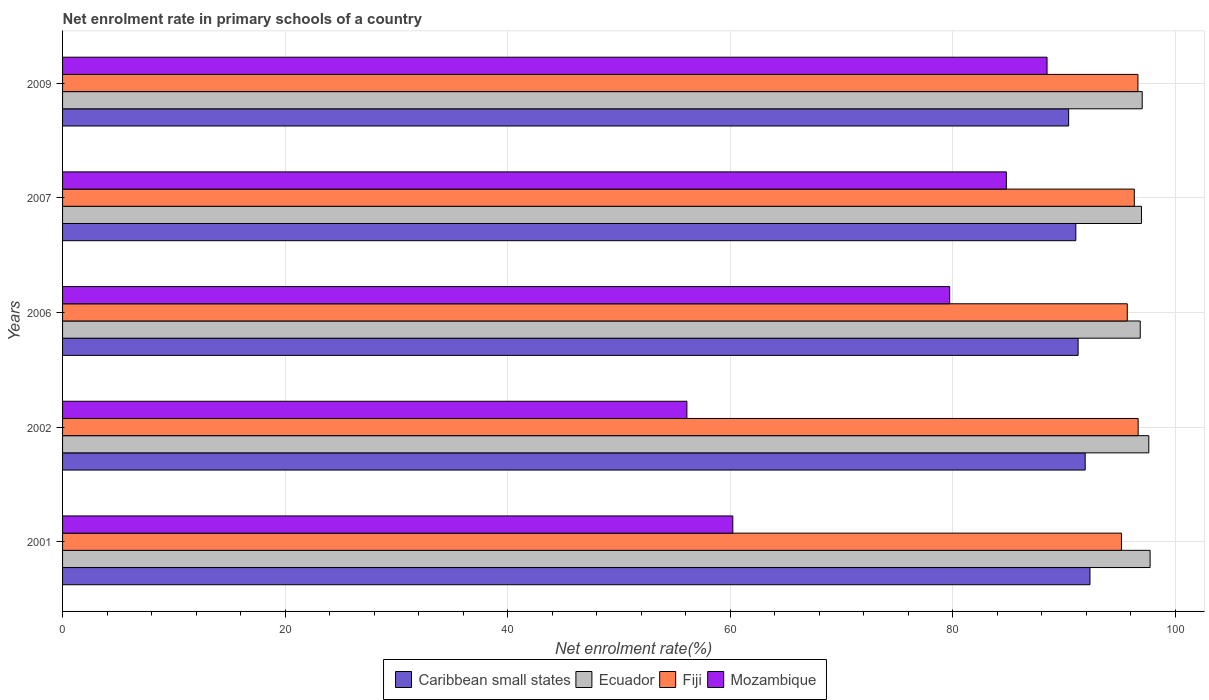How many groups of bars are there?
Give a very brief answer. 5. Are the number of bars per tick equal to the number of legend labels?
Your answer should be very brief. Yes. What is the label of the 5th group of bars from the top?
Your answer should be very brief. 2001. In how many cases, is the number of bars for a given year not equal to the number of legend labels?
Your answer should be very brief. 0. What is the net enrolment rate in primary schools in Mozambique in 2001?
Offer a terse response. 60.24. Across all years, what is the maximum net enrolment rate in primary schools in Caribbean small states?
Give a very brief answer. 92.34. Across all years, what is the minimum net enrolment rate in primary schools in Fiji?
Offer a terse response. 95.17. What is the total net enrolment rate in primary schools in Ecuador in the graph?
Your response must be concise. 486.24. What is the difference between the net enrolment rate in primary schools in Ecuador in 2001 and that in 2007?
Make the answer very short. 0.78. What is the difference between the net enrolment rate in primary schools in Mozambique in 2009 and the net enrolment rate in primary schools in Caribbean small states in 2002?
Offer a very short reply. -3.43. What is the average net enrolment rate in primary schools in Ecuador per year?
Ensure brevity in your answer.  97.25. In the year 2007, what is the difference between the net enrolment rate in primary schools in Mozambique and net enrolment rate in primary schools in Fiji?
Your answer should be very brief. -11.5. In how many years, is the net enrolment rate in primary schools in Fiji greater than 80 %?
Your response must be concise. 5. What is the ratio of the net enrolment rate in primary schools in Ecuador in 2001 to that in 2002?
Offer a very short reply. 1. Is the net enrolment rate in primary schools in Caribbean small states in 2001 less than that in 2009?
Your response must be concise. No. Is the difference between the net enrolment rate in primary schools in Mozambique in 2007 and 2009 greater than the difference between the net enrolment rate in primary schools in Fiji in 2007 and 2009?
Make the answer very short. No. What is the difference between the highest and the second highest net enrolment rate in primary schools in Fiji?
Your answer should be compact. 0.02. What is the difference between the highest and the lowest net enrolment rate in primary schools in Ecuador?
Provide a succinct answer. 0.89. In how many years, is the net enrolment rate in primary schools in Caribbean small states greater than the average net enrolment rate in primary schools in Caribbean small states taken over all years?
Your response must be concise. 2. Is it the case that in every year, the sum of the net enrolment rate in primary schools in Ecuador and net enrolment rate in primary schools in Caribbean small states is greater than the sum of net enrolment rate in primary schools in Fiji and net enrolment rate in primary schools in Mozambique?
Make the answer very short. No. What does the 2nd bar from the top in 2006 represents?
Offer a very short reply. Fiji. What does the 2nd bar from the bottom in 2006 represents?
Your answer should be compact. Ecuador. Is it the case that in every year, the sum of the net enrolment rate in primary schools in Ecuador and net enrolment rate in primary schools in Caribbean small states is greater than the net enrolment rate in primary schools in Fiji?
Provide a succinct answer. Yes. How many years are there in the graph?
Provide a succinct answer. 5. Are the values on the major ticks of X-axis written in scientific E-notation?
Provide a succinct answer. No. How many legend labels are there?
Provide a succinct answer. 4. What is the title of the graph?
Your answer should be very brief. Net enrolment rate in primary schools of a country. What is the label or title of the X-axis?
Offer a very short reply. Net enrolment rate(%). What is the label or title of the Y-axis?
Your response must be concise. Years. What is the Net enrolment rate(%) of Caribbean small states in 2001?
Make the answer very short. 92.34. What is the Net enrolment rate(%) of Ecuador in 2001?
Your answer should be compact. 97.75. What is the Net enrolment rate(%) in Fiji in 2001?
Give a very brief answer. 95.17. What is the Net enrolment rate(%) of Mozambique in 2001?
Offer a very short reply. 60.24. What is the Net enrolment rate(%) in Caribbean small states in 2002?
Offer a very short reply. 91.91. What is the Net enrolment rate(%) in Ecuador in 2002?
Ensure brevity in your answer.  97.63. What is the Net enrolment rate(%) of Fiji in 2002?
Your response must be concise. 96.67. What is the Net enrolment rate(%) of Mozambique in 2002?
Offer a very short reply. 56.11. What is the Net enrolment rate(%) of Caribbean small states in 2006?
Your response must be concise. 91.28. What is the Net enrolment rate(%) of Ecuador in 2006?
Keep it short and to the point. 96.86. What is the Net enrolment rate(%) of Fiji in 2006?
Your answer should be compact. 95.69. What is the Net enrolment rate(%) in Mozambique in 2006?
Your answer should be compact. 79.73. What is the Net enrolment rate(%) in Caribbean small states in 2007?
Your answer should be compact. 91.07. What is the Net enrolment rate(%) in Ecuador in 2007?
Keep it short and to the point. 96.97. What is the Net enrolment rate(%) of Fiji in 2007?
Keep it short and to the point. 96.33. What is the Net enrolment rate(%) of Mozambique in 2007?
Your answer should be compact. 84.83. What is the Net enrolment rate(%) of Caribbean small states in 2009?
Ensure brevity in your answer.  90.42. What is the Net enrolment rate(%) of Ecuador in 2009?
Offer a very short reply. 97.04. What is the Net enrolment rate(%) of Fiji in 2009?
Your answer should be very brief. 96.65. What is the Net enrolment rate(%) in Mozambique in 2009?
Your response must be concise. 88.48. Across all years, what is the maximum Net enrolment rate(%) in Caribbean small states?
Offer a very short reply. 92.34. Across all years, what is the maximum Net enrolment rate(%) of Ecuador?
Give a very brief answer. 97.75. Across all years, what is the maximum Net enrolment rate(%) in Fiji?
Make the answer very short. 96.67. Across all years, what is the maximum Net enrolment rate(%) of Mozambique?
Ensure brevity in your answer.  88.48. Across all years, what is the minimum Net enrolment rate(%) of Caribbean small states?
Provide a succinct answer. 90.42. Across all years, what is the minimum Net enrolment rate(%) in Ecuador?
Make the answer very short. 96.86. Across all years, what is the minimum Net enrolment rate(%) in Fiji?
Keep it short and to the point. 95.17. Across all years, what is the minimum Net enrolment rate(%) in Mozambique?
Offer a terse response. 56.11. What is the total Net enrolment rate(%) in Caribbean small states in the graph?
Offer a very short reply. 457.02. What is the total Net enrolment rate(%) in Ecuador in the graph?
Your response must be concise. 486.24. What is the total Net enrolment rate(%) of Fiji in the graph?
Keep it short and to the point. 480.51. What is the total Net enrolment rate(%) of Mozambique in the graph?
Provide a succinct answer. 369.39. What is the difference between the Net enrolment rate(%) of Caribbean small states in 2001 and that in 2002?
Your answer should be very brief. 0.43. What is the difference between the Net enrolment rate(%) of Ecuador in 2001 and that in 2002?
Provide a short and direct response. 0.12. What is the difference between the Net enrolment rate(%) of Fiji in 2001 and that in 2002?
Keep it short and to the point. -1.5. What is the difference between the Net enrolment rate(%) of Mozambique in 2001 and that in 2002?
Your answer should be very brief. 4.13. What is the difference between the Net enrolment rate(%) in Caribbean small states in 2001 and that in 2006?
Offer a terse response. 1.06. What is the difference between the Net enrolment rate(%) of Ecuador in 2001 and that in 2006?
Your answer should be very brief. 0.89. What is the difference between the Net enrolment rate(%) in Fiji in 2001 and that in 2006?
Give a very brief answer. -0.52. What is the difference between the Net enrolment rate(%) in Mozambique in 2001 and that in 2006?
Provide a short and direct response. -19.49. What is the difference between the Net enrolment rate(%) of Caribbean small states in 2001 and that in 2007?
Your answer should be compact. 1.27. What is the difference between the Net enrolment rate(%) in Ecuador in 2001 and that in 2007?
Your response must be concise. 0.78. What is the difference between the Net enrolment rate(%) of Fiji in 2001 and that in 2007?
Your answer should be compact. -1.15. What is the difference between the Net enrolment rate(%) in Mozambique in 2001 and that in 2007?
Your answer should be compact. -24.59. What is the difference between the Net enrolment rate(%) in Caribbean small states in 2001 and that in 2009?
Your response must be concise. 1.92. What is the difference between the Net enrolment rate(%) of Ecuador in 2001 and that in 2009?
Offer a terse response. 0.71. What is the difference between the Net enrolment rate(%) in Fiji in 2001 and that in 2009?
Ensure brevity in your answer.  -1.48. What is the difference between the Net enrolment rate(%) in Mozambique in 2001 and that in 2009?
Offer a terse response. -28.24. What is the difference between the Net enrolment rate(%) of Caribbean small states in 2002 and that in 2006?
Your answer should be very brief. 0.63. What is the difference between the Net enrolment rate(%) in Ecuador in 2002 and that in 2006?
Your response must be concise. 0.77. What is the difference between the Net enrolment rate(%) in Fiji in 2002 and that in 2006?
Offer a very short reply. 0.98. What is the difference between the Net enrolment rate(%) of Mozambique in 2002 and that in 2006?
Provide a short and direct response. -23.62. What is the difference between the Net enrolment rate(%) in Caribbean small states in 2002 and that in 2007?
Ensure brevity in your answer.  0.84. What is the difference between the Net enrolment rate(%) in Ecuador in 2002 and that in 2007?
Keep it short and to the point. 0.66. What is the difference between the Net enrolment rate(%) of Fiji in 2002 and that in 2007?
Make the answer very short. 0.35. What is the difference between the Net enrolment rate(%) in Mozambique in 2002 and that in 2007?
Give a very brief answer. -28.71. What is the difference between the Net enrolment rate(%) in Caribbean small states in 2002 and that in 2009?
Provide a short and direct response. 1.49. What is the difference between the Net enrolment rate(%) of Ecuador in 2002 and that in 2009?
Your answer should be compact. 0.59. What is the difference between the Net enrolment rate(%) in Fiji in 2002 and that in 2009?
Offer a very short reply. 0.02. What is the difference between the Net enrolment rate(%) in Mozambique in 2002 and that in 2009?
Your answer should be compact. -32.37. What is the difference between the Net enrolment rate(%) of Caribbean small states in 2006 and that in 2007?
Offer a terse response. 0.21. What is the difference between the Net enrolment rate(%) in Ecuador in 2006 and that in 2007?
Give a very brief answer. -0.11. What is the difference between the Net enrolment rate(%) in Fiji in 2006 and that in 2007?
Your answer should be compact. -0.63. What is the difference between the Net enrolment rate(%) of Mozambique in 2006 and that in 2007?
Keep it short and to the point. -5.1. What is the difference between the Net enrolment rate(%) in Caribbean small states in 2006 and that in 2009?
Give a very brief answer. 0.85. What is the difference between the Net enrolment rate(%) in Ecuador in 2006 and that in 2009?
Ensure brevity in your answer.  -0.18. What is the difference between the Net enrolment rate(%) in Fiji in 2006 and that in 2009?
Your answer should be very brief. -0.96. What is the difference between the Net enrolment rate(%) of Mozambique in 2006 and that in 2009?
Offer a very short reply. -8.75. What is the difference between the Net enrolment rate(%) in Caribbean small states in 2007 and that in 2009?
Provide a succinct answer. 0.65. What is the difference between the Net enrolment rate(%) in Ecuador in 2007 and that in 2009?
Make the answer very short. -0.07. What is the difference between the Net enrolment rate(%) in Fiji in 2007 and that in 2009?
Ensure brevity in your answer.  -0.33. What is the difference between the Net enrolment rate(%) in Mozambique in 2007 and that in 2009?
Provide a succinct answer. -3.66. What is the difference between the Net enrolment rate(%) of Caribbean small states in 2001 and the Net enrolment rate(%) of Ecuador in 2002?
Ensure brevity in your answer.  -5.29. What is the difference between the Net enrolment rate(%) of Caribbean small states in 2001 and the Net enrolment rate(%) of Fiji in 2002?
Give a very brief answer. -4.33. What is the difference between the Net enrolment rate(%) in Caribbean small states in 2001 and the Net enrolment rate(%) in Mozambique in 2002?
Keep it short and to the point. 36.23. What is the difference between the Net enrolment rate(%) in Ecuador in 2001 and the Net enrolment rate(%) in Fiji in 2002?
Offer a very short reply. 1.07. What is the difference between the Net enrolment rate(%) in Ecuador in 2001 and the Net enrolment rate(%) in Mozambique in 2002?
Ensure brevity in your answer.  41.63. What is the difference between the Net enrolment rate(%) in Fiji in 2001 and the Net enrolment rate(%) in Mozambique in 2002?
Provide a succinct answer. 39.06. What is the difference between the Net enrolment rate(%) in Caribbean small states in 2001 and the Net enrolment rate(%) in Ecuador in 2006?
Offer a very short reply. -4.52. What is the difference between the Net enrolment rate(%) in Caribbean small states in 2001 and the Net enrolment rate(%) in Fiji in 2006?
Make the answer very short. -3.35. What is the difference between the Net enrolment rate(%) in Caribbean small states in 2001 and the Net enrolment rate(%) in Mozambique in 2006?
Give a very brief answer. 12.61. What is the difference between the Net enrolment rate(%) in Ecuador in 2001 and the Net enrolment rate(%) in Fiji in 2006?
Your response must be concise. 2.05. What is the difference between the Net enrolment rate(%) of Ecuador in 2001 and the Net enrolment rate(%) of Mozambique in 2006?
Provide a short and direct response. 18.02. What is the difference between the Net enrolment rate(%) of Fiji in 2001 and the Net enrolment rate(%) of Mozambique in 2006?
Your response must be concise. 15.44. What is the difference between the Net enrolment rate(%) of Caribbean small states in 2001 and the Net enrolment rate(%) of Ecuador in 2007?
Offer a terse response. -4.63. What is the difference between the Net enrolment rate(%) of Caribbean small states in 2001 and the Net enrolment rate(%) of Fiji in 2007?
Give a very brief answer. -3.99. What is the difference between the Net enrolment rate(%) of Caribbean small states in 2001 and the Net enrolment rate(%) of Mozambique in 2007?
Make the answer very short. 7.51. What is the difference between the Net enrolment rate(%) of Ecuador in 2001 and the Net enrolment rate(%) of Fiji in 2007?
Keep it short and to the point. 1.42. What is the difference between the Net enrolment rate(%) of Ecuador in 2001 and the Net enrolment rate(%) of Mozambique in 2007?
Your answer should be compact. 12.92. What is the difference between the Net enrolment rate(%) of Fiji in 2001 and the Net enrolment rate(%) of Mozambique in 2007?
Give a very brief answer. 10.35. What is the difference between the Net enrolment rate(%) in Caribbean small states in 2001 and the Net enrolment rate(%) in Ecuador in 2009?
Your response must be concise. -4.7. What is the difference between the Net enrolment rate(%) in Caribbean small states in 2001 and the Net enrolment rate(%) in Fiji in 2009?
Ensure brevity in your answer.  -4.31. What is the difference between the Net enrolment rate(%) in Caribbean small states in 2001 and the Net enrolment rate(%) in Mozambique in 2009?
Make the answer very short. 3.86. What is the difference between the Net enrolment rate(%) in Ecuador in 2001 and the Net enrolment rate(%) in Fiji in 2009?
Provide a short and direct response. 1.1. What is the difference between the Net enrolment rate(%) in Ecuador in 2001 and the Net enrolment rate(%) in Mozambique in 2009?
Your answer should be very brief. 9.26. What is the difference between the Net enrolment rate(%) in Fiji in 2001 and the Net enrolment rate(%) in Mozambique in 2009?
Your answer should be very brief. 6.69. What is the difference between the Net enrolment rate(%) of Caribbean small states in 2002 and the Net enrolment rate(%) of Ecuador in 2006?
Your answer should be very brief. -4.95. What is the difference between the Net enrolment rate(%) in Caribbean small states in 2002 and the Net enrolment rate(%) in Fiji in 2006?
Keep it short and to the point. -3.78. What is the difference between the Net enrolment rate(%) of Caribbean small states in 2002 and the Net enrolment rate(%) of Mozambique in 2006?
Provide a short and direct response. 12.18. What is the difference between the Net enrolment rate(%) in Ecuador in 2002 and the Net enrolment rate(%) in Fiji in 2006?
Make the answer very short. 1.94. What is the difference between the Net enrolment rate(%) in Ecuador in 2002 and the Net enrolment rate(%) in Mozambique in 2006?
Your answer should be compact. 17.9. What is the difference between the Net enrolment rate(%) of Fiji in 2002 and the Net enrolment rate(%) of Mozambique in 2006?
Ensure brevity in your answer.  16.94. What is the difference between the Net enrolment rate(%) of Caribbean small states in 2002 and the Net enrolment rate(%) of Ecuador in 2007?
Your answer should be very brief. -5.06. What is the difference between the Net enrolment rate(%) of Caribbean small states in 2002 and the Net enrolment rate(%) of Fiji in 2007?
Your answer should be compact. -4.42. What is the difference between the Net enrolment rate(%) in Caribbean small states in 2002 and the Net enrolment rate(%) in Mozambique in 2007?
Offer a very short reply. 7.09. What is the difference between the Net enrolment rate(%) in Ecuador in 2002 and the Net enrolment rate(%) in Fiji in 2007?
Ensure brevity in your answer.  1.3. What is the difference between the Net enrolment rate(%) in Ecuador in 2002 and the Net enrolment rate(%) in Mozambique in 2007?
Make the answer very short. 12.8. What is the difference between the Net enrolment rate(%) of Fiji in 2002 and the Net enrolment rate(%) of Mozambique in 2007?
Provide a short and direct response. 11.85. What is the difference between the Net enrolment rate(%) of Caribbean small states in 2002 and the Net enrolment rate(%) of Ecuador in 2009?
Provide a short and direct response. -5.12. What is the difference between the Net enrolment rate(%) in Caribbean small states in 2002 and the Net enrolment rate(%) in Fiji in 2009?
Offer a terse response. -4.74. What is the difference between the Net enrolment rate(%) in Caribbean small states in 2002 and the Net enrolment rate(%) in Mozambique in 2009?
Your answer should be compact. 3.43. What is the difference between the Net enrolment rate(%) in Ecuador in 2002 and the Net enrolment rate(%) in Fiji in 2009?
Provide a succinct answer. 0.98. What is the difference between the Net enrolment rate(%) in Ecuador in 2002 and the Net enrolment rate(%) in Mozambique in 2009?
Provide a short and direct response. 9.15. What is the difference between the Net enrolment rate(%) in Fiji in 2002 and the Net enrolment rate(%) in Mozambique in 2009?
Provide a succinct answer. 8.19. What is the difference between the Net enrolment rate(%) of Caribbean small states in 2006 and the Net enrolment rate(%) of Ecuador in 2007?
Provide a succinct answer. -5.69. What is the difference between the Net enrolment rate(%) of Caribbean small states in 2006 and the Net enrolment rate(%) of Fiji in 2007?
Provide a succinct answer. -5.05. What is the difference between the Net enrolment rate(%) of Caribbean small states in 2006 and the Net enrolment rate(%) of Mozambique in 2007?
Give a very brief answer. 6.45. What is the difference between the Net enrolment rate(%) of Ecuador in 2006 and the Net enrolment rate(%) of Fiji in 2007?
Provide a short and direct response. 0.53. What is the difference between the Net enrolment rate(%) of Ecuador in 2006 and the Net enrolment rate(%) of Mozambique in 2007?
Ensure brevity in your answer.  12.03. What is the difference between the Net enrolment rate(%) of Fiji in 2006 and the Net enrolment rate(%) of Mozambique in 2007?
Provide a succinct answer. 10.87. What is the difference between the Net enrolment rate(%) of Caribbean small states in 2006 and the Net enrolment rate(%) of Ecuador in 2009?
Provide a short and direct response. -5.76. What is the difference between the Net enrolment rate(%) in Caribbean small states in 2006 and the Net enrolment rate(%) in Fiji in 2009?
Your answer should be very brief. -5.38. What is the difference between the Net enrolment rate(%) in Caribbean small states in 2006 and the Net enrolment rate(%) in Mozambique in 2009?
Keep it short and to the point. 2.79. What is the difference between the Net enrolment rate(%) of Ecuador in 2006 and the Net enrolment rate(%) of Fiji in 2009?
Provide a short and direct response. 0.21. What is the difference between the Net enrolment rate(%) of Ecuador in 2006 and the Net enrolment rate(%) of Mozambique in 2009?
Make the answer very short. 8.38. What is the difference between the Net enrolment rate(%) of Fiji in 2006 and the Net enrolment rate(%) of Mozambique in 2009?
Provide a short and direct response. 7.21. What is the difference between the Net enrolment rate(%) of Caribbean small states in 2007 and the Net enrolment rate(%) of Ecuador in 2009?
Offer a very short reply. -5.97. What is the difference between the Net enrolment rate(%) in Caribbean small states in 2007 and the Net enrolment rate(%) in Fiji in 2009?
Offer a very short reply. -5.58. What is the difference between the Net enrolment rate(%) in Caribbean small states in 2007 and the Net enrolment rate(%) in Mozambique in 2009?
Your answer should be very brief. 2.59. What is the difference between the Net enrolment rate(%) of Ecuador in 2007 and the Net enrolment rate(%) of Fiji in 2009?
Keep it short and to the point. 0.32. What is the difference between the Net enrolment rate(%) of Ecuador in 2007 and the Net enrolment rate(%) of Mozambique in 2009?
Make the answer very short. 8.49. What is the difference between the Net enrolment rate(%) of Fiji in 2007 and the Net enrolment rate(%) of Mozambique in 2009?
Your answer should be compact. 7.84. What is the average Net enrolment rate(%) in Caribbean small states per year?
Ensure brevity in your answer.  91.4. What is the average Net enrolment rate(%) in Ecuador per year?
Offer a very short reply. 97.25. What is the average Net enrolment rate(%) in Fiji per year?
Your answer should be compact. 96.1. What is the average Net enrolment rate(%) of Mozambique per year?
Your answer should be very brief. 73.88. In the year 2001, what is the difference between the Net enrolment rate(%) of Caribbean small states and Net enrolment rate(%) of Ecuador?
Offer a terse response. -5.41. In the year 2001, what is the difference between the Net enrolment rate(%) in Caribbean small states and Net enrolment rate(%) in Fiji?
Ensure brevity in your answer.  -2.83. In the year 2001, what is the difference between the Net enrolment rate(%) of Caribbean small states and Net enrolment rate(%) of Mozambique?
Your answer should be very brief. 32.1. In the year 2001, what is the difference between the Net enrolment rate(%) in Ecuador and Net enrolment rate(%) in Fiji?
Your answer should be very brief. 2.58. In the year 2001, what is the difference between the Net enrolment rate(%) of Ecuador and Net enrolment rate(%) of Mozambique?
Your answer should be compact. 37.51. In the year 2001, what is the difference between the Net enrolment rate(%) in Fiji and Net enrolment rate(%) in Mozambique?
Your answer should be very brief. 34.93. In the year 2002, what is the difference between the Net enrolment rate(%) of Caribbean small states and Net enrolment rate(%) of Ecuador?
Offer a very short reply. -5.72. In the year 2002, what is the difference between the Net enrolment rate(%) in Caribbean small states and Net enrolment rate(%) in Fiji?
Provide a succinct answer. -4.76. In the year 2002, what is the difference between the Net enrolment rate(%) in Caribbean small states and Net enrolment rate(%) in Mozambique?
Offer a very short reply. 35.8. In the year 2002, what is the difference between the Net enrolment rate(%) in Ecuador and Net enrolment rate(%) in Fiji?
Ensure brevity in your answer.  0.96. In the year 2002, what is the difference between the Net enrolment rate(%) in Ecuador and Net enrolment rate(%) in Mozambique?
Offer a very short reply. 41.52. In the year 2002, what is the difference between the Net enrolment rate(%) of Fiji and Net enrolment rate(%) of Mozambique?
Give a very brief answer. 40.56. In the year 2006, what is the difference between the Net enrolment rate(%) in Caribbean small states and Net enrolment rate(%) in Ecuador?
Offer a very short reply. -5.58. In the year 2006, what is the difference between the Net enrolment rate(%) in Caribbean small states and Net enrolment rate(%) in Fiji?
Provide a short and direct response. -4.42. In the year 2006, what is the difference between the Net enrolment rate(%) in Caribbean small states and Net enrolment rate(%) in Mozambique?
Provide a succinct answer. 11.55. In the year 2006, what is the difference between the Net enrolment rate(%) of Ecuador and Net enrolment rate(%) of Fiji?
Keep it short and to the point. 1.17. In the year 2006, what is the difference between the Net enrolment rate(%) of Ecuador and Net enrolment rate(%) of Mozambique?
Ensure brevity in your answer.  17.13. In the year 2006, what is the difference between the Net enrolment rate(%) in Fiji and Net enrolment rate(%) in Mozambique?
Provide a short and direct response. 15.96. In the year 2007, what is the difference between the Net enrolment rate(%) of Caribbean small states and Net enrolment rate(%) of Ecuador?
Offer a very short reply. -5.9. In the year 2007, what is the difference between the Net enrolment rate(%) in Caribbean small states and Net enrolment rate(%) in Fiji?
Your response must be concise. -5.26. In the year 2007, what is the difference between the Net enrolment rate(%) of Caribbean small states and Net enrolment rate(%) of Mozambique?
Your response must be concise. 6.24. In the year 2007, what is the difference between the Net enrolment rate(%) in Ecuador and Net enrolment rate(%) in Fiji?
Offer a very short reply. 0.64. In the year 2007, what is the difference between the Net enrolment rate(%) in Ecuador and Net enrolment rate(%) in Mozambique?
Keep it short and to the point. 12.14. In the year 2007, what is the difference between the Net enrolment rate(%) of Fiji and Net enrolment rate(%) of Mozambique?
Your answer should be very brief. 11.5. In the year 2009, what is the difference between the Net enrolment rate(%) in Caribbean small states and Net enrolment rate(%) in Ecuador?
Provide a succinct answer. -6.61. In the year 2009, what is the difference between the Net enrolment rate(%) of Caribbean small states and Net enrolment rate(%) of Fiji?
Ensure brevity in your answer.  -6.23. In the year 2009, what is the difference between the Net enrolment rate(%) of Caribbean small states and Net enrolment rate(%) of Mozambique?
Your answer should be compact. 1.94. In the year 2009, what is the difference between the Net enrolment rate(%) of Ecuador and Net enrolment rate(%) of Fiji?
Your answer should be compact. 0.38. In the year 2009, what is the difference between the Net enrolment rate(%) of Ecuador and Net enrolment rate(%) of Mozambique?
Offer a terse response. 8.55. In the year 2009, what is the difference between the Net enrolment rate(%) in Fiji and Net enrolment rate(%) in Mozambique?
Your response must be concise. 8.17. What is the ratio of the Net enrolment rate(%) in Caribbean small states in 2001 to that in 2002?
Your answer should be very brief. 1. What is the ratio of the Net enrolment rate(%) of Fiji in 2001 to that in 2002?
Your answer should be very brief. 0.98. What is the ratio of the Net enrolment rate(%) of Mozambique in 2001 to that in 2002?
Your response must be concise. 1.07. What is the ratio of the Net enrolment rate(%) in Caribbean small states in 2001 to that in 2006?
Offer a terse response. 1.01. What is the ratio of the Net enrolment rate(%) of Ecuador in 2001 to that in 2006?
Provide a succinct answer. 1.01. What is the ratio of the Net enrolment rate(%) in Mozambique in 2001 to that in 2006?
Offer a very short reply. 0.76. What is the ratio of the Net enrolment rate(%) in Caribbean small states in 2001 to that in 2007?
Provide a succinct answer. 1.01. What is the ratio of the Net enrolment rate(%) of Ecuador in 2001 to that in 2007?
Offer a very short reply. 1.01. What is the ratio of the Net enrolment rate(%) of Fiji in 2001 to that in 2007?
Your answer should be compact. 0.99. What is the ratio of the Net enrolment rate(%) in Mozambique in 2001 to that in 2007?
Make the answer very short. 0.71. What is the ratio of the Net enrolment rate(%) of Caribbean small states in 2001 to that in 2009?
Give a very brief answer. 1.02. What is the ratio of the Net enrolment rate(%) in Ecuador in 2001 to that in 2009?
Give a very brief answer. 1.01. What is the ratio of the Net enrolment rate(%) of Fiji in 2001 to that in 2009?
Provide a succinct answer. 0.98. What is the ratio of the Net enrolment rate(%) in Mozambique in 2001 to that in 2009?
Offer a very short reply. 0.68. What is the ratio of the Net enrolment rate(%) of Ecuador in 2002 to that in 2006?
Your answer should be compact. 1.01. What is the ratio of the Net enrolment rate(%) in Fiji in 2002 to that in 2006?
Provide a succinct answer. 1.01. What is the ratio of the Net enrolment rate(%) in Mozambique in 2002 to that in 2006?
Provide a short and direct response. 0.7. What is the ratio of the Net enrolment rate(%) in Caribbean small states in 2002 to that in 2007?
Give a very brief answer. 1.01. What is the ratio of the Net enrolment rate(%) of Ecuador in 2002 to that in 2007?
Offer a very short reply. 1.01. What is the ratio of the Net enrolment rate(%) of Fiji in 2002 to that in 2007?
Your response must be concise. 1. What is the ratio of the Net enrolment rate(%) of Mozambique in 2002 to that in 2007?
Offer a terse response. 0.66. What is the ratio of the Net enrolment rate(%) of Caribbean small states in 2002 to that in 2009?
Your response must be concise. 1.02. What is the ratio of the Net enrolment rate(%) in Ecuador in 2002 to that in 2009?
Provide a short and direct response. 1.01. What is the ratio of the Net enrolment rate(%) in Mozambique in 2002 to that in 2009?
Your response must be concise. 0.63. What is the ratio of the Net enrolment rate(%) in Ecuador in 2006 to that in 2007?
Your answer should be very brief. 1. What is the ratio of the Net enrolment rate(%) of Mozambique in 2006 to that in 2007?
Offer a very short reply. 0.94. What is the ratio of the Net enrolment rate(%) in Caribbean small states in 2006 to that in 2009?
Ensure brevity in your answer.  1.01. What is the ratio of the Net enrolment rate(%) of Ecuador in 2006 to that in 2009?
Provide a short and direct response. 1. What is the ratio of the Net enrolment rate(%) in Fiji in 2006 to that in 2009?
Give a very brief answer. 0.99. What is the ratio of the Net enrolment rate(%) in Mozambique in 2006 to that in 2009?
Offer a terse response. 0.9. What is the ratio of the Net enrolment rate(%) of Caribbean small states in 2007 to that in 2009?
Provide a short and direct response. 1.01. What is the ratio of the Net enrolment rate(%) in Ecuador in 2007 to that in 2009?
Offer a very short reply. 1. What is the ratio of the Net enrolment rate(%) of Mozambique in 2007 to that in 2009?
Offer a terse response. 0.96. What is the difference between the highest and the second highest Net enrolment rate(%) of Caribbean small states?
Provide a short and direct response. 0.43. What is the difference between the highest and the second highest Net enrolment rate(%) in Ecuador?
Your response must be concise. 0.12. What is the difference between the highest and the second highest Net enrolment rate(%) in Fiji?
Provide a short and direct response. 0.02. What is the difference between the highest and the second highest Net enrolment rate(%) of Mozambique?
Offer a very short reply. 3.66. What is the difference between the highest and the lowest Net enrolment rate(%) of Caribbean small states?
Your answer should be compact. 1.92. What is the difference between the highest and the lowest Net enrolment rate(%) of Ecuador?
Your response must be concise. 0.89. What is the difference between the highest and the lowest Net enrolment rate(%) in Fiji?
Make the answer very short. 1.5. What is the difference between the highest and the lowest Net enrolment rate(%) of Mozambique?
Give a very brief answer. 32.37. 